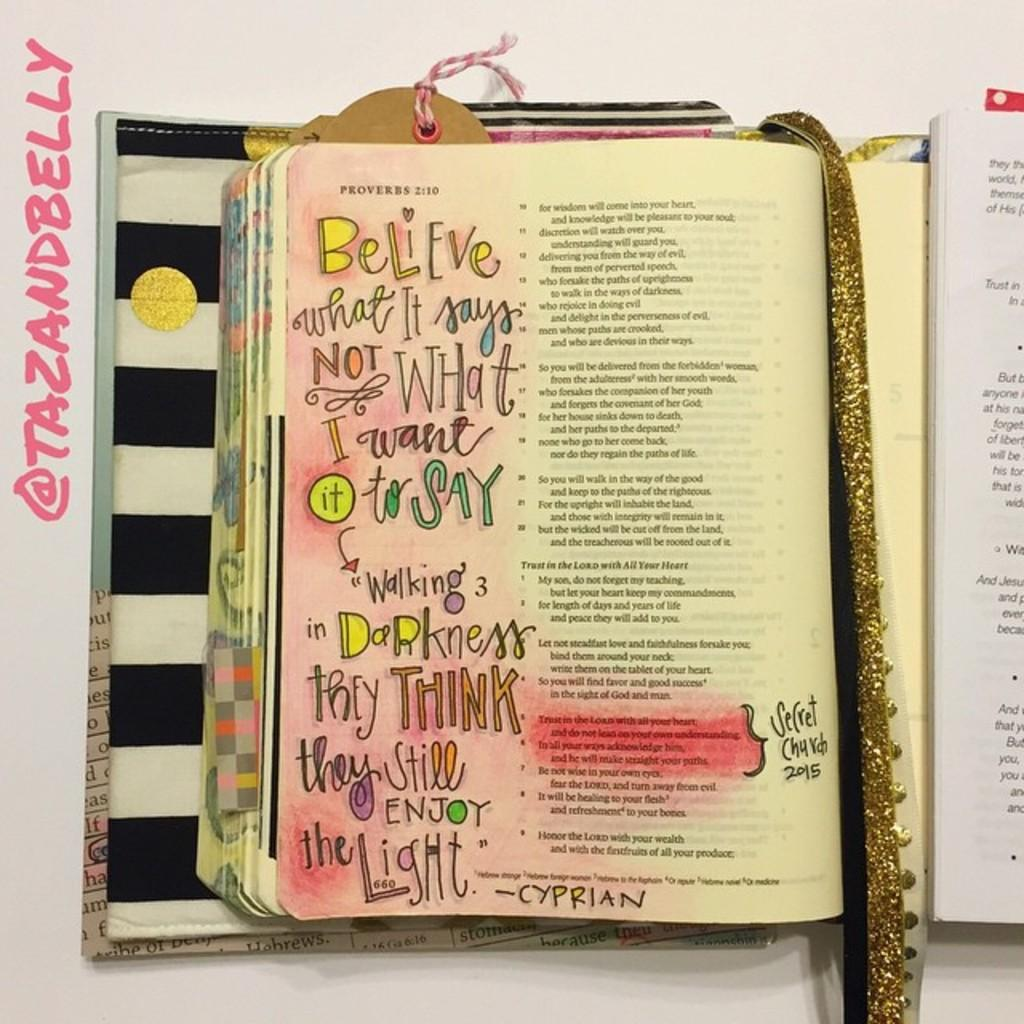Provide a one-sentence caption for the provided image. Book open with a glitter gold ribbon in the middle that says believe. 